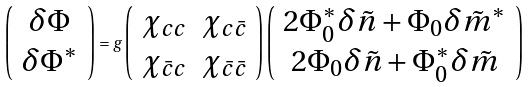<formula> <loc_0><loc_0><loc_500><loc_500>\left ( \begin{array} { c } \delta \Phi \\ \delta \Phi ^ { * } \end{array} \right ) = g \left ( \begin{array} { c c } \chi _ { c c } & \chi _ { c \bar { c } } \\ \chi _ { \bar { c } c } & \chi _ { \bar { c } \bar { c } } \end{array} \right ) \left ( \begin{array} { c } 2 \Phi _ { 0 } ^ { * } \delta \tilde { n } + \Phi _ { 0 } \delta \tilde { m } ^ { * } \\ 2 \Phi _ { 0 } \delta \tilde { n } + \Phi _ { 0 } ^ { * } \delta \tilde { m } \end{array} \right )</formula> 